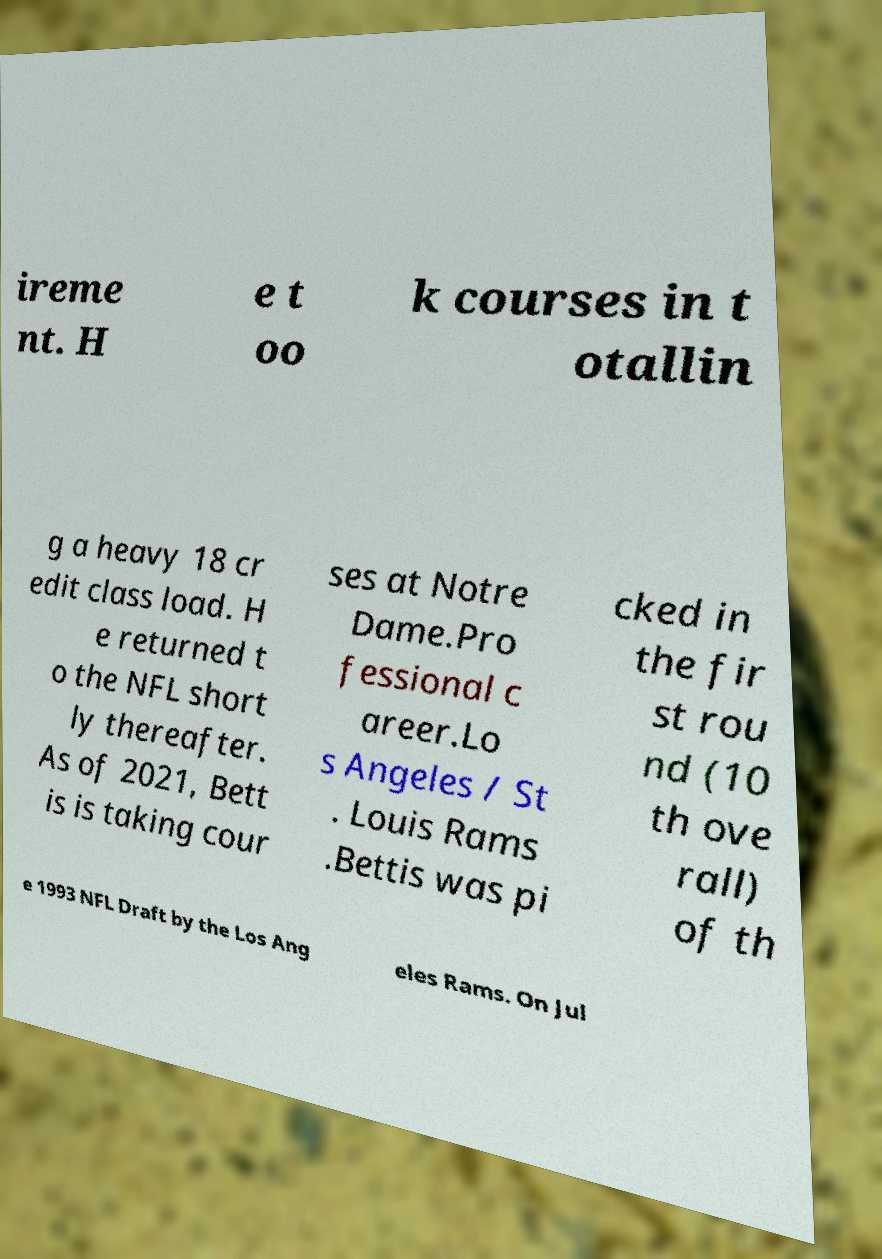I need the written content from this picture converted into text. Can you do that? ireme nt. H e t oo k courses in t otallin g a heavy 18 cr edit class load. H e returned t o the NFL short ly thereafter. As of 2021, Bett is is taking cour ses at Notre Dame.Pro fessional c areer.Lo s Angeles / St . Louis Rams .Bettis was pi cked in the fir st rou nd (10 th ove rall) of th e 1993 NFL Draft by the Los Ang eles Rams. On Jul 